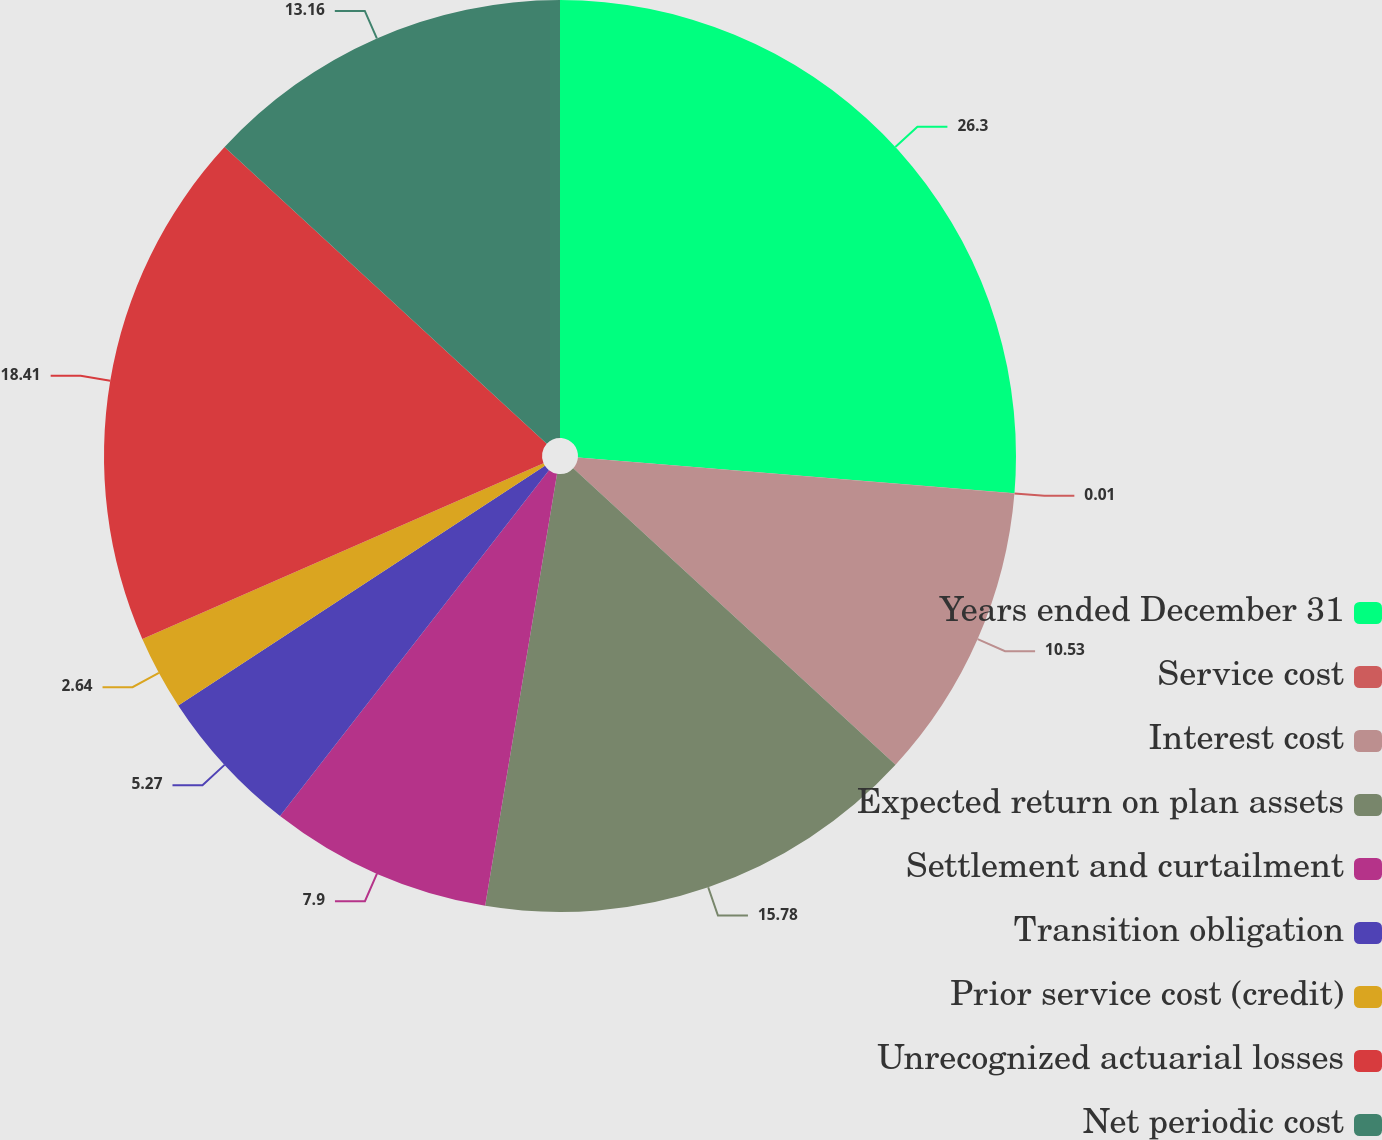Convert chart to OTSL. <chart><loc_0><loc_0><loc_500><loc_500><pie_chart><fcel>Years ended December 31<fcel>Service cost<fcel>Interest cost<fcel>Expected return on plan assets<fcel>Settlement and curtailment<fcel>Transition obligation<fcel>Prior service cost (credit)<fcel>Unrecognized actuarial losses<fcel>Net periodic cost<nl><fcel>26.31%<fcel>0.01%<fcel>10.53%<fcel>15.79%<fcel>7.9%<fcel>5.27%<fcel>2.64%<fcel>18.42%<fcel>13.16%<nl></chart> 